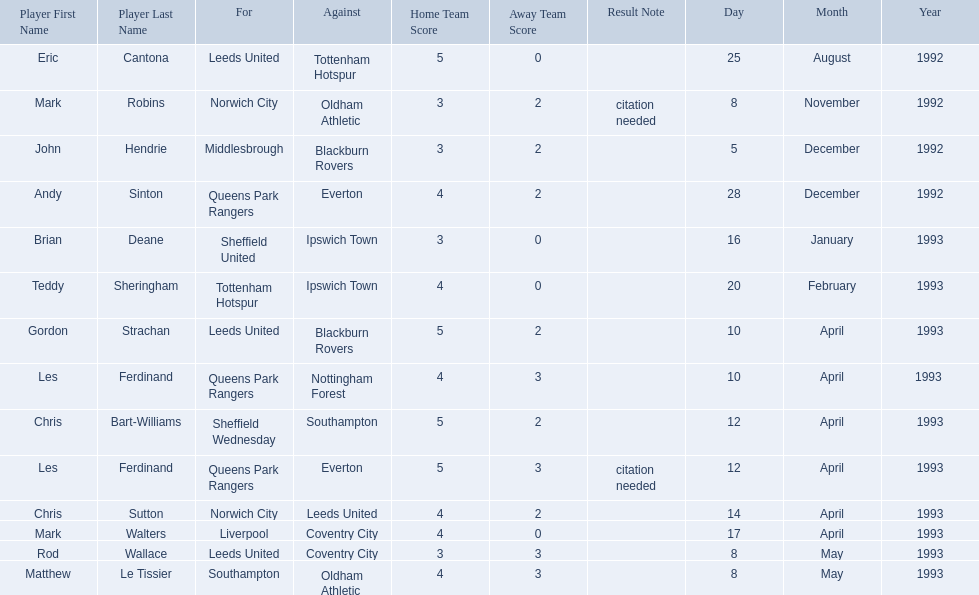Who are all the players? Eric Cantona, Mark Robins, John Hendrie, Andy Sinton, Brian Deane, Teddy Sheringham, Gordon Strachan, Les Ferdinand, Chris Bart-Williams, Les Ferdinand, Chris Sutton, Mark Walters, Rod Wallace, Matthew Le Tissier. What were their results? 5–0, 3–2[citation needed], 3–2, 4–2, 3–0, 4–0, 5–2, 4–3, 5–2, 5–3[citation needed], 4–2, 4–0, 3–3, 4–3. Which player tied with mark robins? John Hendrie. 